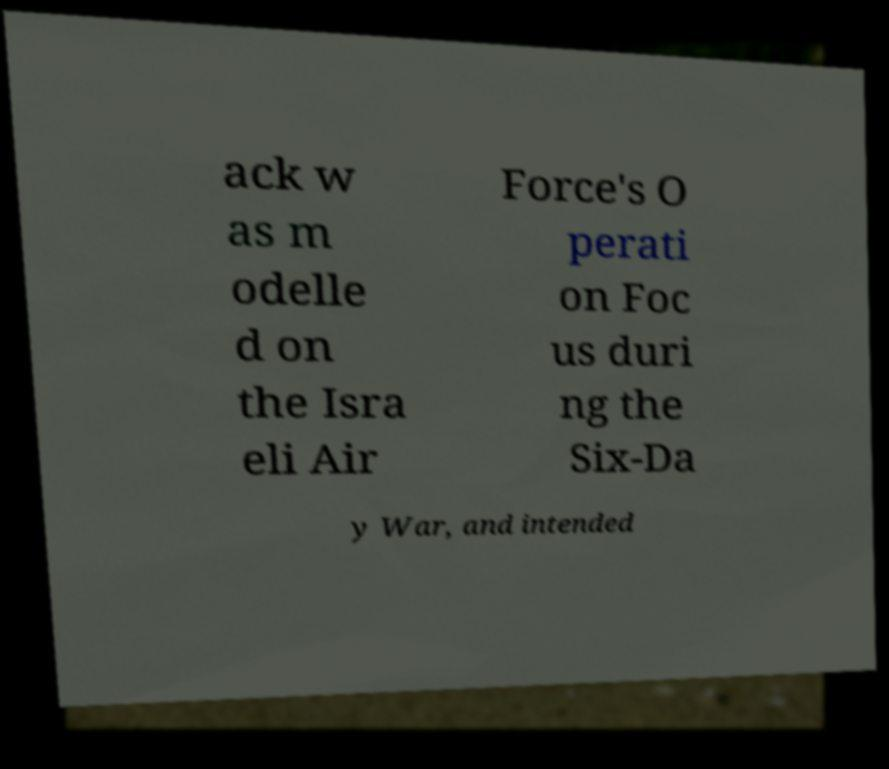Can you accurately transcribe the text from the provided image for me? ack w as m odelle d on the Isra eli Air Force's O perati on Foc us duri ng the Six-Da y War, and intended 